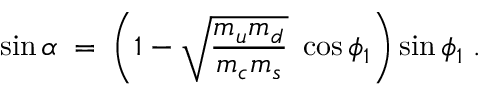<formula> <loc_0><loc_0><loc_500><loc_500>\sin \alpha \, = \, \left ( 1 - \sqrt { \frac { m _ { u } m _ { d } } { m _ { c } m _ { s } } } \cos \phi _ { 1 } \right ) \sin \phi _ { 1 } \, .</formula> 